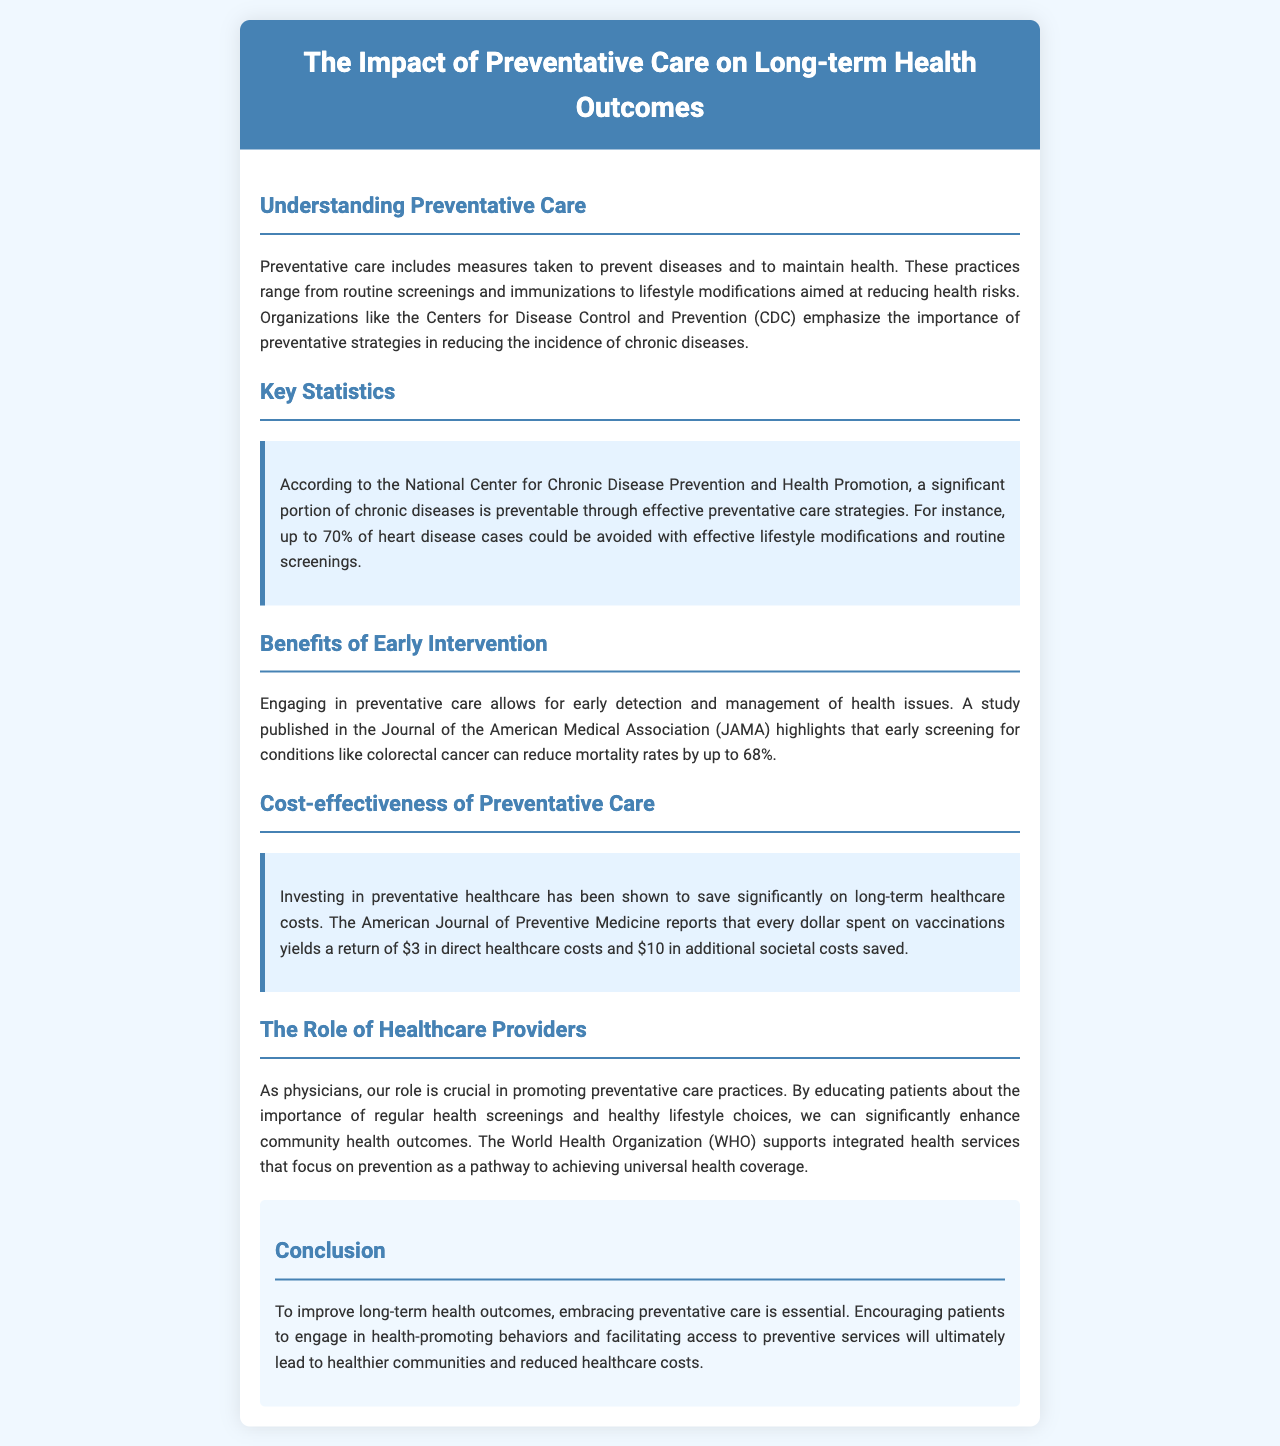What is preventative care? Preventative care includes measures taken to prevent diseases and to maintain health, such as routine screenings and lifestyle modifications.
Answer: Measures to prevent diseases What percentage of heart disease cases could be avoided? According to the document, up to 70% of heart disease cases could be avoided with effective lifestyle modifications and routine screenings.
Answer: 70% What is the mortality rate reduction for early screening for colorectal cancer? The document mentions that early screening can reduce mortality rates by up to 68%.
Answer: 68% How much is saved in healthcare costs for every dollar spent on vaccinations? The American Journal of Preventive Medicine reports a return of $3 in direct healthcare costs.
Answer: $3 What organization emphasizes the importance of preventative strategies? The Centers for Disease Control and Prevention (CDC) emphasizes the importance of preventative strategies in the document.
Answer: CDC What is the main role of healthcare providers in preventative care? The role of healthcare providers is crucial in promoting preventative care practices and educating patients about their importance.
Answer: Educating patients What is stated as essential to improve long-term health outcomes? Embracing preventative care is essential to improve long-term health outcomes according to the conclusion.
Answer: Embracing preventative care How can preventative care impact healthcare costs according to the document? Investing in preventative healthcare has been shown to save significantly on long-term healthcare costs.
Answer: Saves on long-term costs What pathway does the WHO support to achieve universal health coverage? The World Health Organization supports integrated health services that focus on prevention.
Answer: Integrated health services 